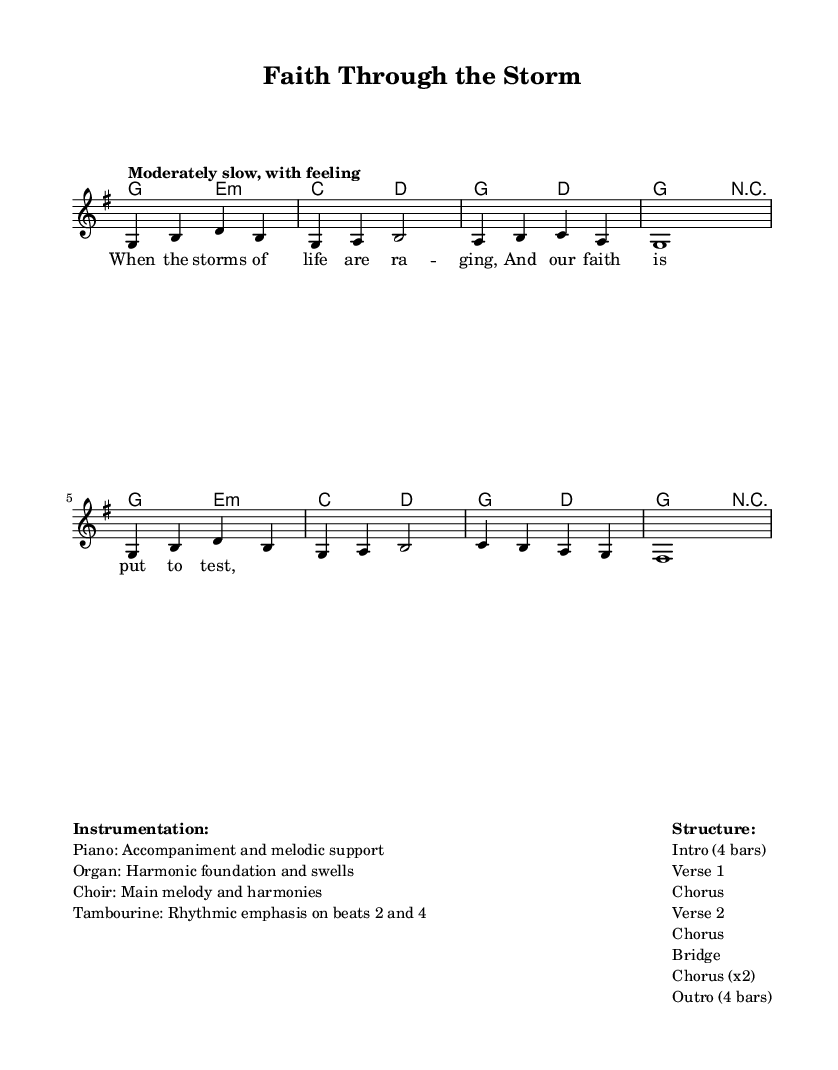What is the key signature of this music? The key signature is G major, which has one sharp (F#). This can be identified by looking at the key signature at the beginning of the staff, indicating that all F notes will be sharpened.
Answer: G major What is the time signature of this music? The time signature is 4/4, which means there are four beats in each measure and the quarter note gets one beat. This is visible at the beginning of the staff, showing a "4" over a "4".
Answer: 4/4 What is the tempo marking for this piece? The tempo marking is "Moderately slow, with feeling". This is found in the tempo section at the top of the score, indicating how the piece should be played.
Answer: Moderately slow, with feeling How many measures does the intro consist of? The intro consists of 4 measures, as outlined in the structure section of the markup, specifically stating "Intro (4 bars)".
Answer: 4 measures Which instruments are primarily involved in this composition? The primary instruments involved are the piano, organ, choir, and tambourine. This is detailed in the instrumentation section of the markup, listing each instrument's role.
Answer: Piano, Organ, Choir, Tambourine What is the final section of the piece called? The final section is called "Outro", which can be found in the structure details under the last entry, showing it as part of the music's flow.
Answer: Outro 